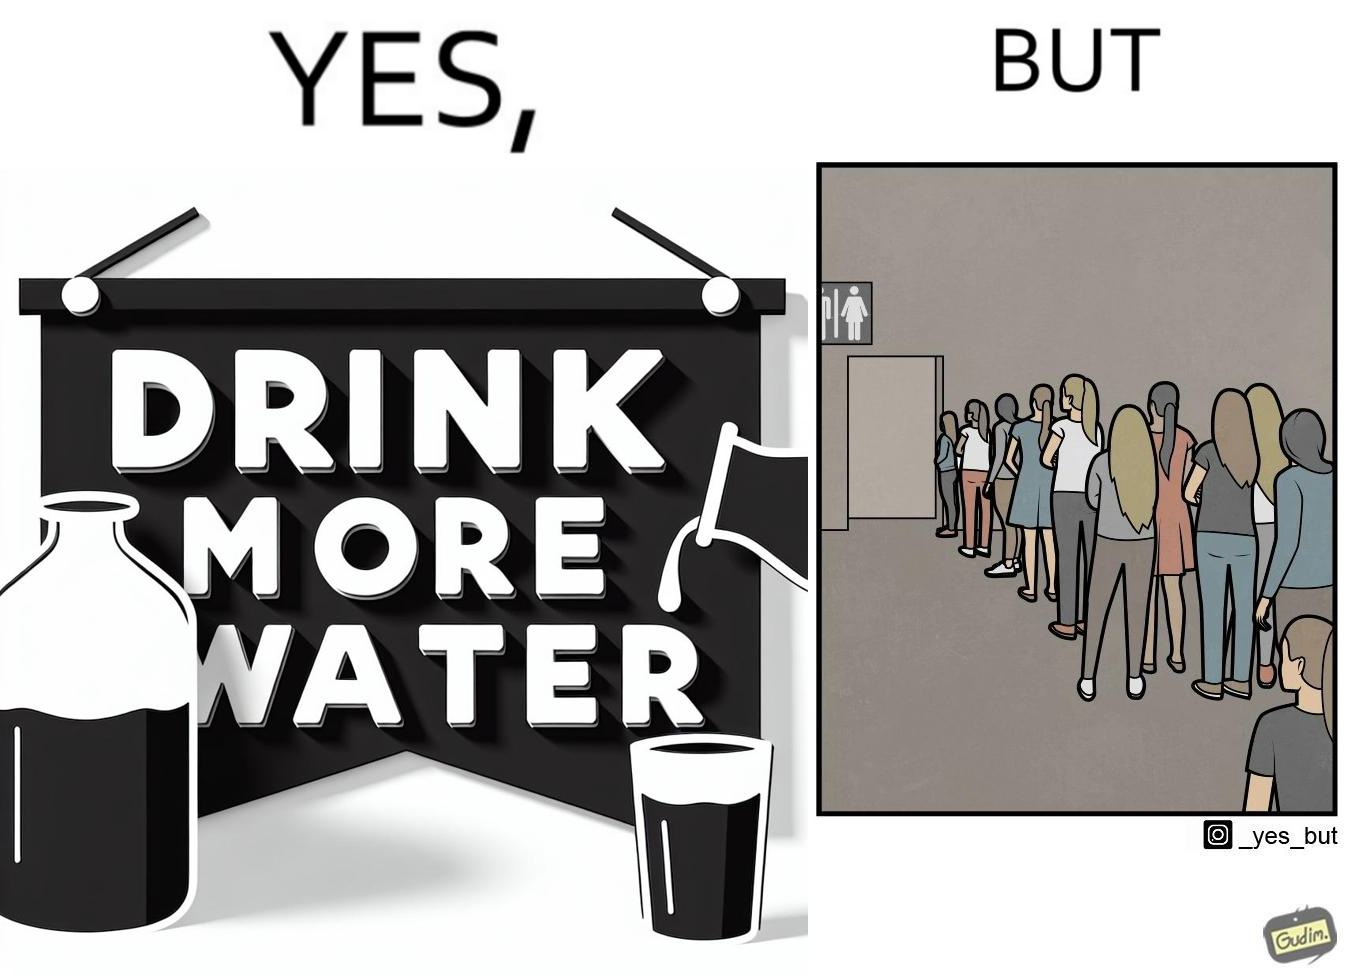Does this image contain satire or humor? Yes, this image is satirical. 